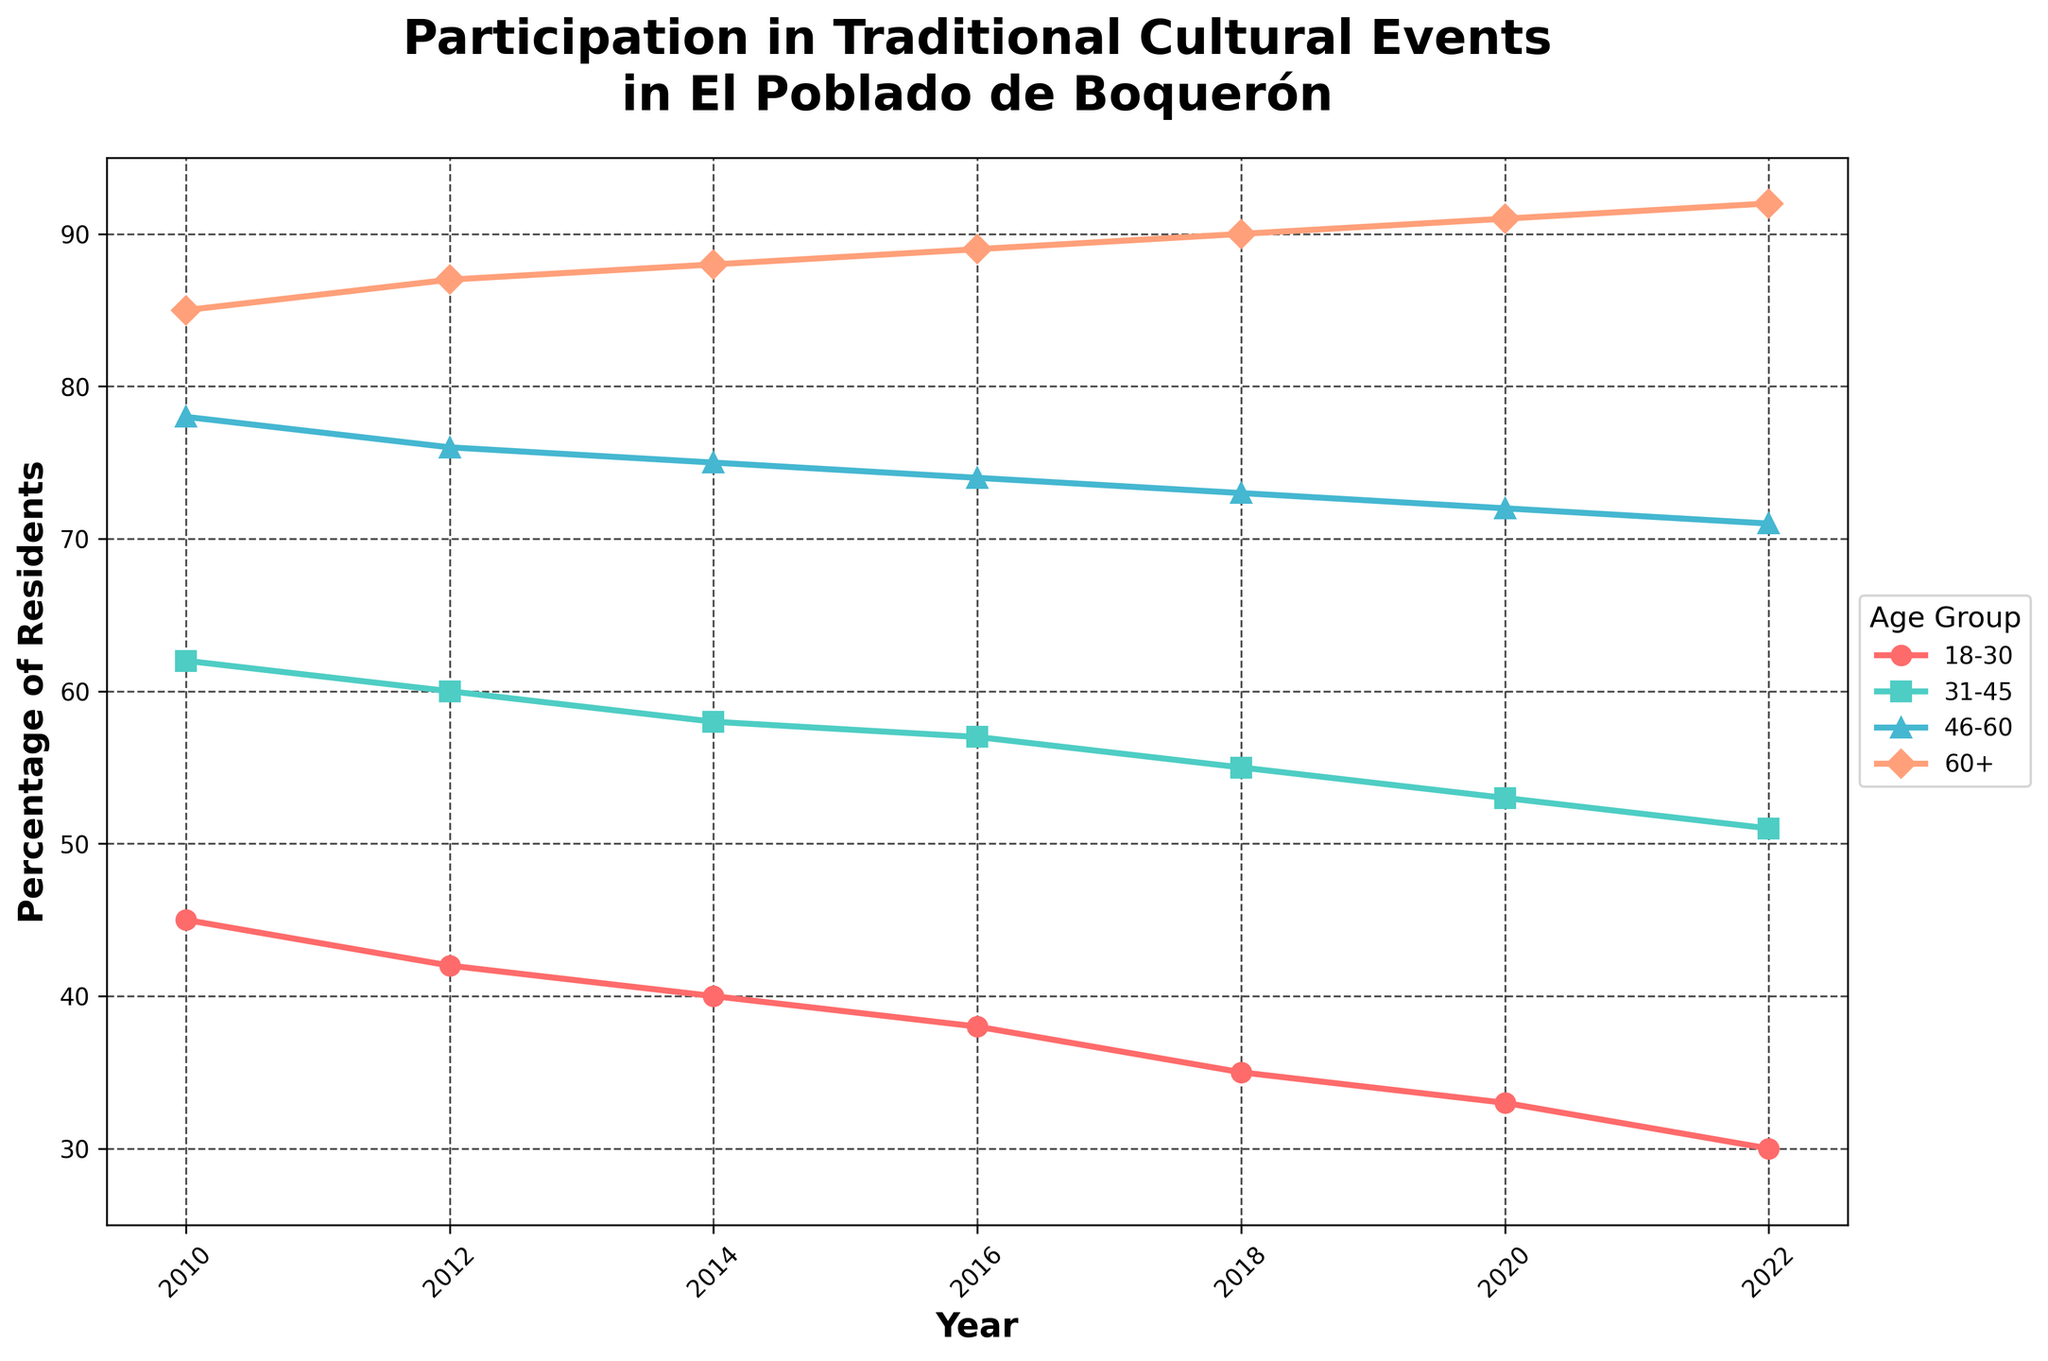What is the overall trend for the 18-30 age group's participation from 2010 to 2022? The percentage of residents aged 18-30 participating in traditional cultural events decreases gradually from 45% in 2010 to 30% in 2022. To determine this, we look at the points on the line corresponding to the 18-30 age group and observe the trend over time.
Answer: Decreasing Between which years did the 60+ age group see the most significant increase in participation? From the figure, we can see that the percentage increases each year. To find the most significant increase, we need to compare the differences year by year: 2010-2012 (2%), 2012-2014 (1%), 2014-2016 (1%), 2016-2018 (1%), 2018-2020 (1%), 2020-2022 (1%). The biggest increase is between 2010 and 2012.
Answer: 2010-2012 Which age group had the smallest decrease in participation from 2010 to 2022? We need to calculate the differences for each age group from 2010 to 2022:
18-30: 45 - 30 = 15
31-45: 62 - 51 = 11
46-60: 78 - 71 = 7
60+: 85 - 92 = -7 (an increase)
The 60+ age group had an increase, while the 46-60 group had the smallest decrease in participation.
Answer: 46-60 In which year did the 31-45 age group's participation fall below 60%? Observing the line for the 31-45 age group, we see that the percentage drops below 60% in 2018. Before that year, their participation percentage is above 60%.
Answer: 2018 Compare the participation levels between the 18-30 and 60+ age groups in 2020. From the figure, we observe the values on the y-axis for the year 2020: 18-30 age group has a participation level of 33%, and the 60+ age group has a level of 91%.
Answer: 60+ has higher participation By how much did the participation of the 46-60 age group decrease from 2010 to 2022? To find the decrease, we subtract the 2022 value (71%) from the 2010 value (78%): 78 - 71 = 7%.
Answer: 7% What is the average participation rate for the 31-45 age group across all years? To calculate the average, we sum up the percentages from all given years and divide by the number of years:
(62 + 60 + 58 + 57 + 55 + 53 + 51) / 7 = 396 / 7 ≈ 56.57%.
Answer: 56.57% Which age group ends with the highest participation rate in 2022? Observing the endpoints for all age group lines in 2022, the 60+ age group ends at the highest point on the y-axis, which is 92%.
Answer: 60+ How does the participation of the 31-45 age group in 2016 compare to that of the 18-30 age group in the same year? In 2016, the percentage for the 31-45 age group is 57%, while the 18-30 age group is 38%. The 31-45 age group has a higher participation rate.
Answer: 31-45 is higher 